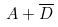Convert formula to latex. <formula><loc_0><loc_0><loc_500><loc_500>A + \overline { D }</formula> 